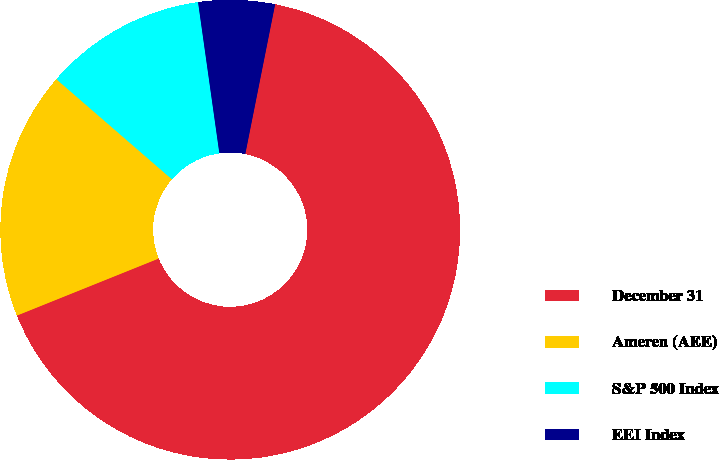<chart> <loc_0><loc_0><loc_500><loc_500><pie_chart><fcel>December 31<fcel>Ameren (AEE)<fcel>S&P 500 Index<fcel>EEI Index<nl><fcel>65.78%<fcel>17.45%<fcel>11.41%<fcel>5.36%<nl></chart> 